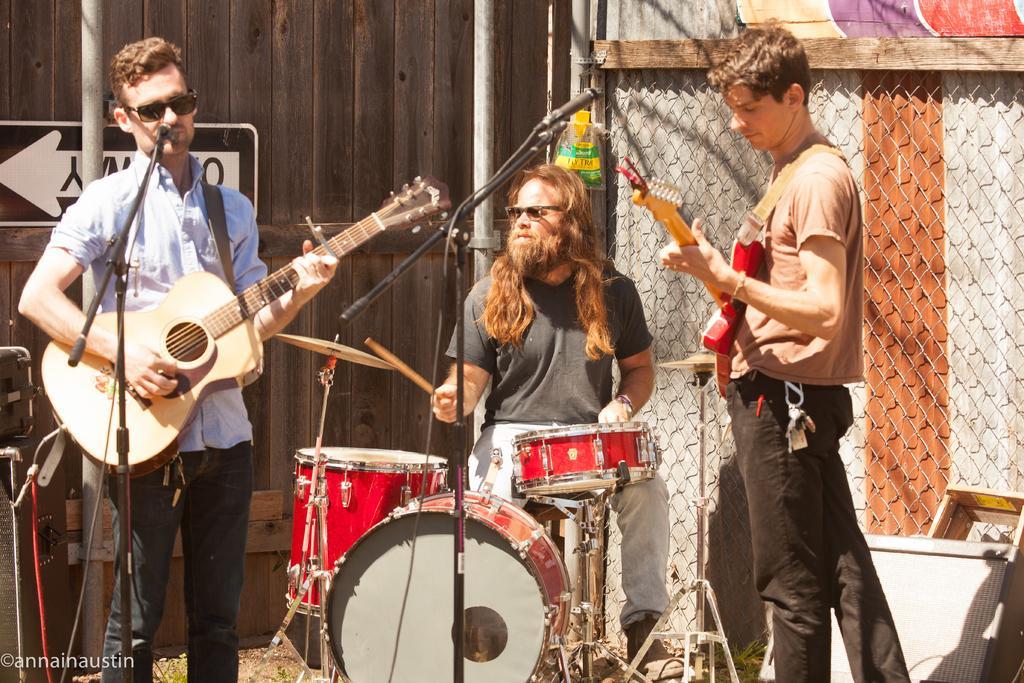How would you summarize this image in a sentence or two? In this picture we can see three persons. These two are playing guitars and he is playing drums. On the background there is a pole. 